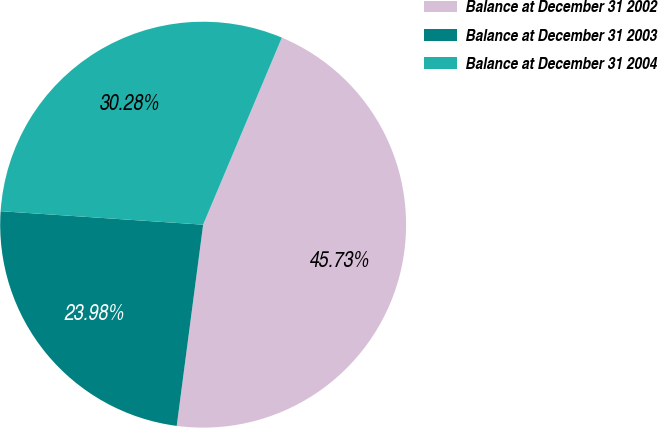Convert chart. <chart><loc_0><loc_0><loc_500><loc_500><pie_chart><fcel>Balance at December 31 2002<fcel>Balance at December 31 2003<fcel>Balance at December 31 2004<nl><fcel>45.73%<fcel>23.98%<fcel>30.28%<nl></chart> 